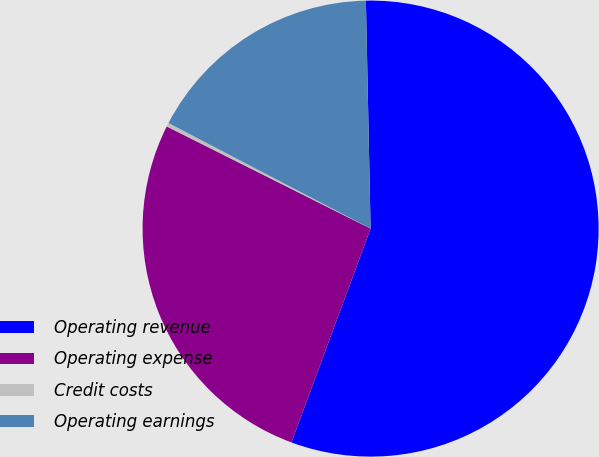<chart> <loc_0><loc_0><loc_500><loc_500><pie_chart><fcel>Operating revenue<fcel>Operating expense<fcel>Credit costs<fcel>Operating earnings<nl><fcel>55.97%<fcel>26.75%<fcel>0.27%<fcel>17.01%<nl></chart> 